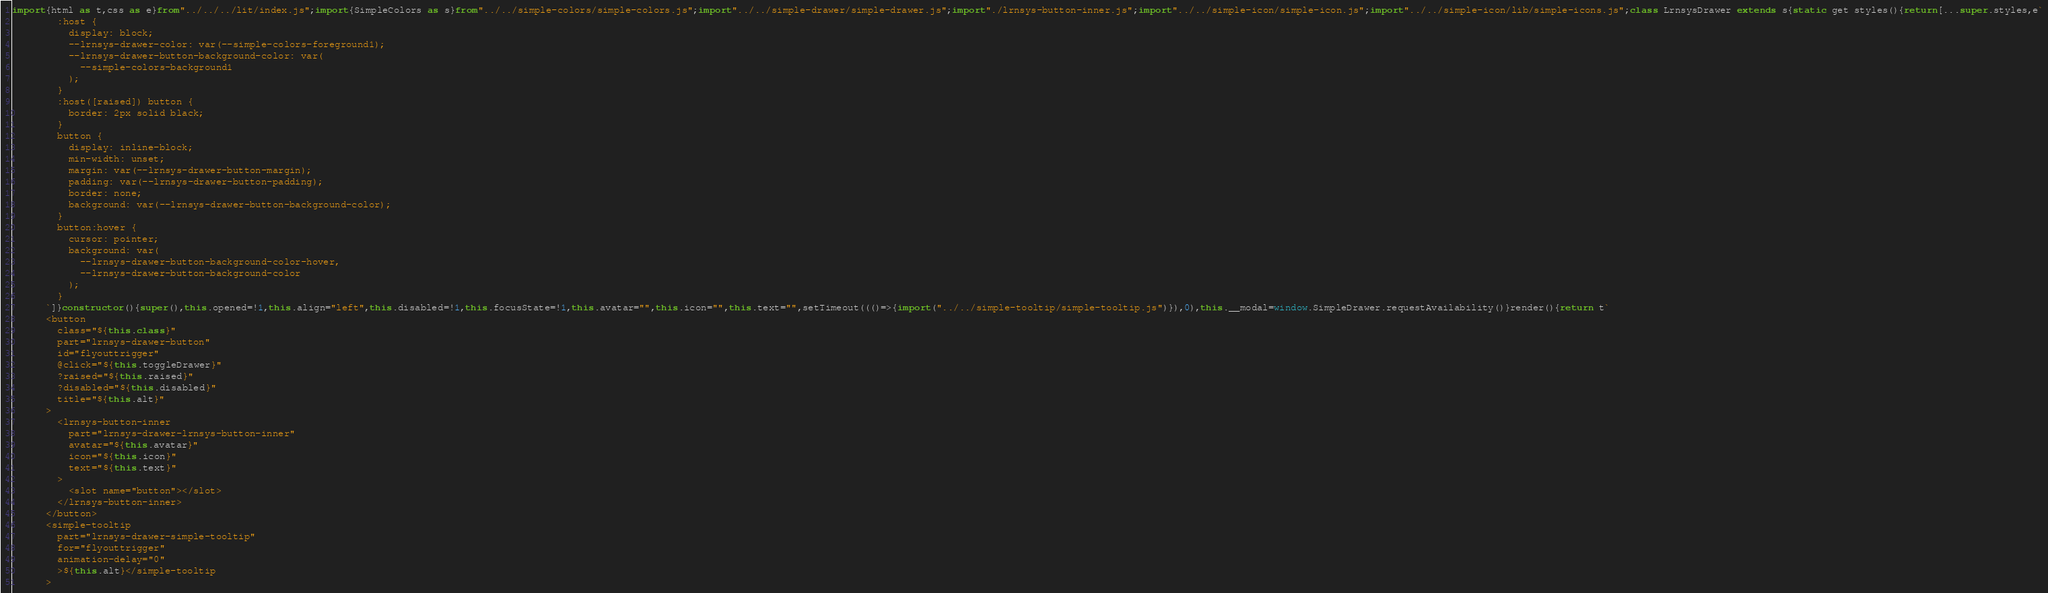Convert code to text. <code><loc_0><loc_0><loc_500><loc_500><_JavaScript_>import{html as t,css as e}from"../../../lit/index.js";import{SimpleColors as s}from"../../simple-colors/simple-colors.js";import"../../simple-drawer/simple-drawer.js";import"./lrnsys-button-inner.js";import"../../simple-icon/simple-icon.js";import"../../simple-icon/lib/simple-icons.js";class LrnsysDrawer extends s{static get styles(){return[...super.styles,e`
        :host {
          display: block;
          --lrnsys-drawer-color: var(--simple-colors-foreground1);
          --lrnsys-drawer-button-background-color: var(
            --simple-colors-background1
          );
        }
        :host([raised]) button {
          border: 2px solid black;
        }
        button {
          display: inline-block;
          min-width: unset;
          margin: var(--lrnsys-drawer-button-margin);
          padding: var(--lrnsys-drawer-button-padding);
          border: none;
          background: var(--lrnsys-drawer-button-background-color);
        }
        button:hover {
          cursor: pointer;
          background: var(
            --lrnsys-drawer-button-background-color-hover,
            --lrnsys-drawer-button-background-color
          );
        }
      `]}constructor(){super(),this.opened=!1,this.align="left",this.disabled=!1,this.focusState=!1,this.avatar="",this.icon="",this.text="",setTimeout((()=>{import("../../simple-tooltip/simple-tooltip.js")}),0),this.__modal=window.SimpleDrawer.requestAvailability()}render(){return t`
      <button
        class="${this.class}"
        part="lrnsys-drawer-button"
        id="flyouttrigger"
        @click="${this.toggleDrawer}"
        ?raised="${this.raised}"
        ?disabled="${this.disabled}"
        title="${this.alt}"
      >
        <lrnsys-button-inner
          part="lrnsys-drawer-lrnsys-button-inner"
          avatar="${this.avatar}"
          icon="${this.icon}"
          text="${this.text}"
        >
          <slot name="button"></slot>
        </lrnsys-button-inner>
      </button>
      <simple-tooltip
        part="lrnsys-drawer-simple-tooltip"
        for="flyouttrigger"
        animation-delay="0"
        >${this.alt}</simple-tooltip
      ></code> 